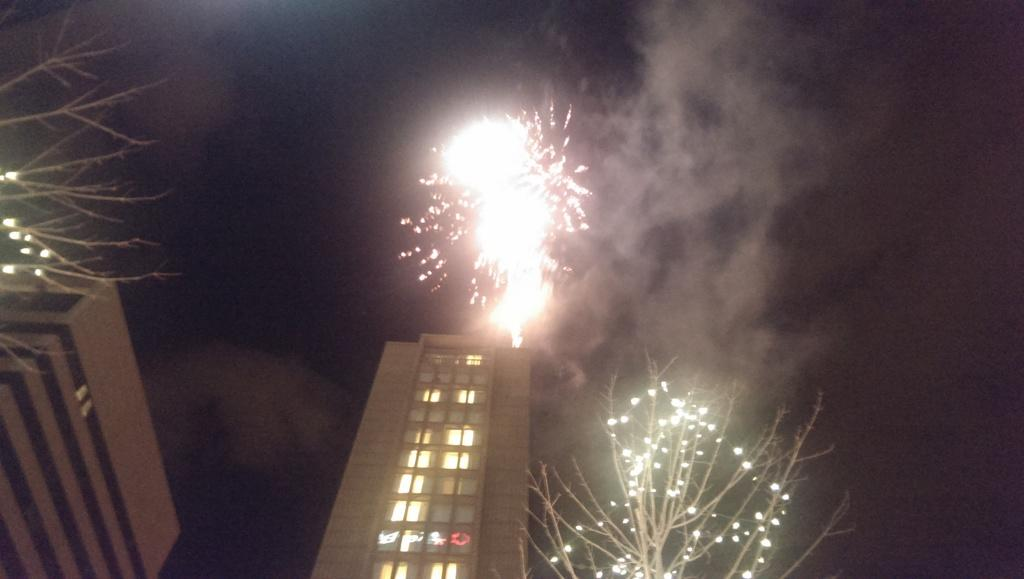How many trees are present in the image? There are two trees in the image. What is unique about the appearance of the trees? The trees are decorated with lights. What structures can be seen behind the trees? There are two buildings behind the trees. What is happening in the sky in the image? Fireworks are glowing in the sky. What type of advertisement can be seen on the trees in the image? There is no advertisement present on the trees in the image; they are simply decorated with lights. 